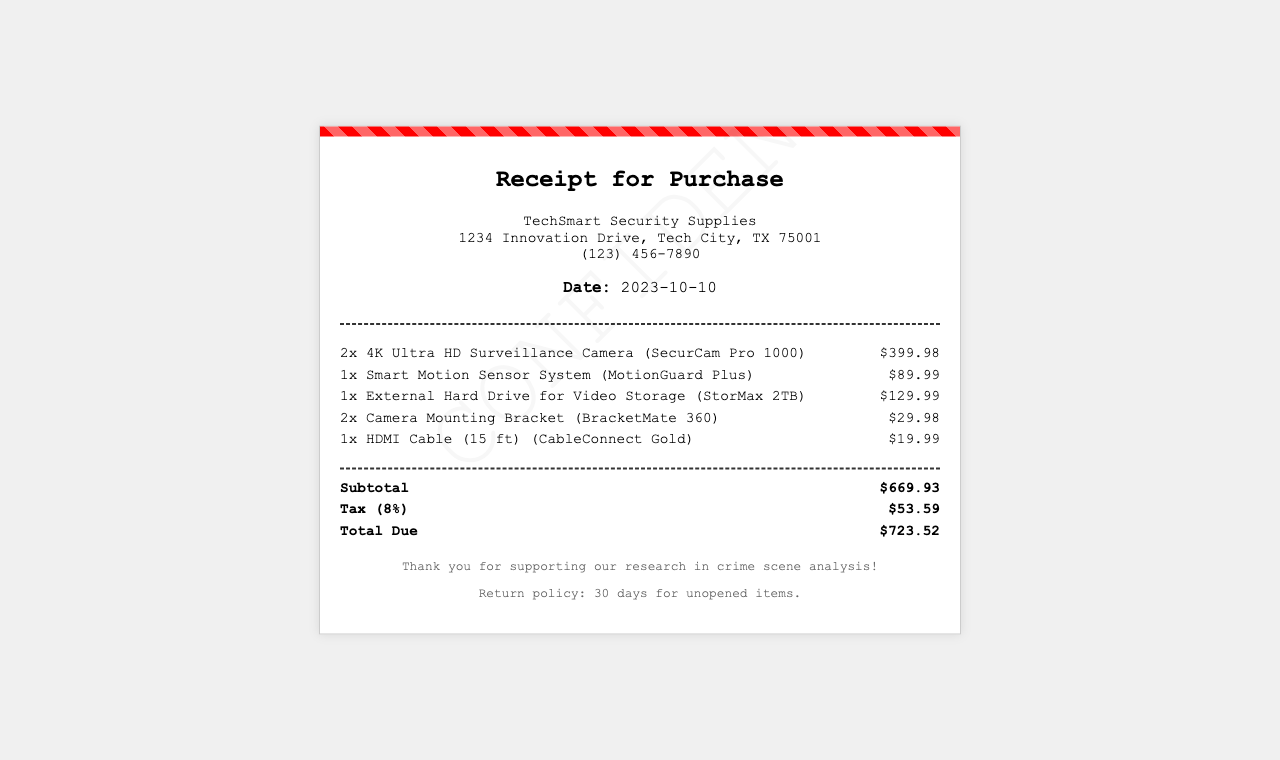what is the name of the store? The name is mentioned clearly at the top of the receipt as "TechSmart Security Supplies."
Answer: TechSmart Security Supplies what is the date of purchase? The date is specified in the header of the receipt as "2023-10-10."
Answer: 2023-10-10 how many 4K Ultra HD Surveillance Cameras were purchased? The receipt details that two units of this item were bought.
Answer: 2 what is the total amount due? The total amount due is clearly listed in the summary section of the receipt as "$723.52."
Answer: $723.52 what is the subtotal for the purchased items? The subtotal is mentioned just before the tax in the summary as "$669.93."
Answer: $669.93 what is the tax percentage applied? The tax amount section states that the tax rate is "8%."
Answer: 8% which item has the highest cost? The item prices indicate that the "4K Ultra HD Surveillance Camera" is the most expensive at "$399.98."
Answer: 4K Ultra HD Surveillance Camera what is the return policy for items? The return policy is described in the footer as "30 days for unopened items."
Answer: 30 days for unopened items how much does an HDMI Cable cost? The price of the HDMI Cable is listed under the items as "$19.99."
Answer: $19.99 